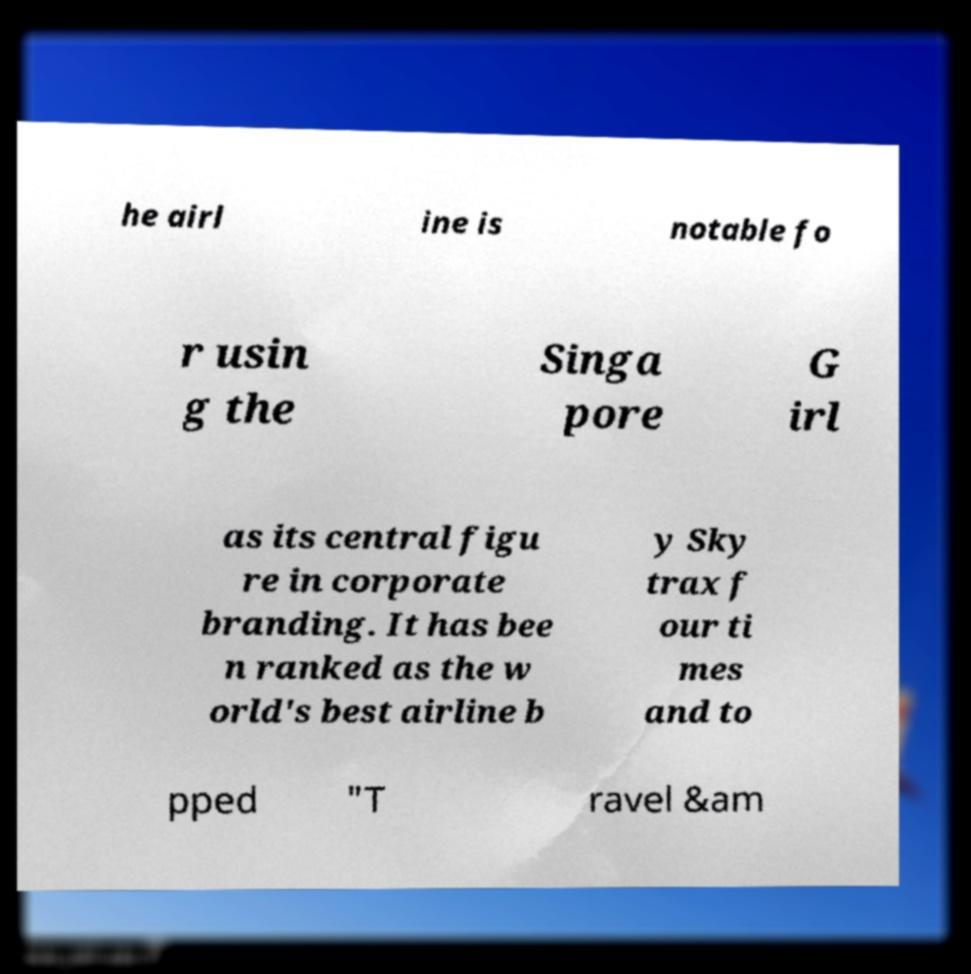Please identify and transcribe the text found in this image. he airl ine is notable fo r usin g the Singa pore G irl as its central figu re in corporate branding. It has bee n ranked as the w orld's best airline b y Sky trax f our ti mes and to pped "T ravel &am 